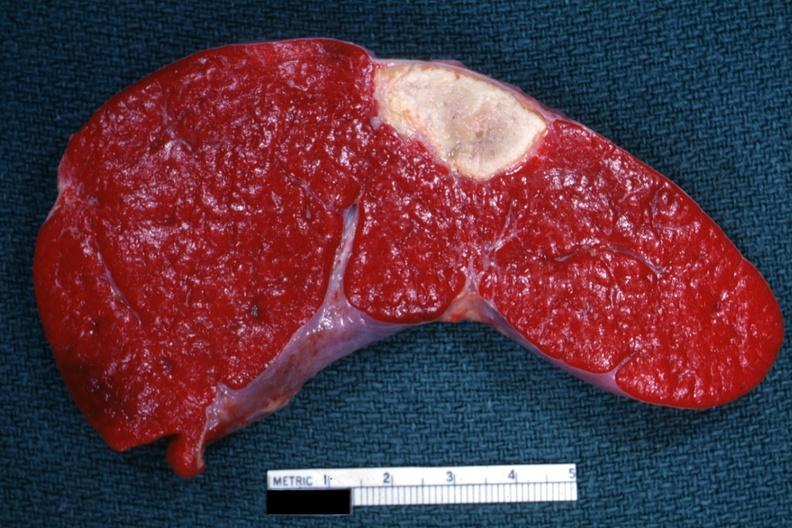where is this part in?
Answer the question using a single word or phrase. Spleen 